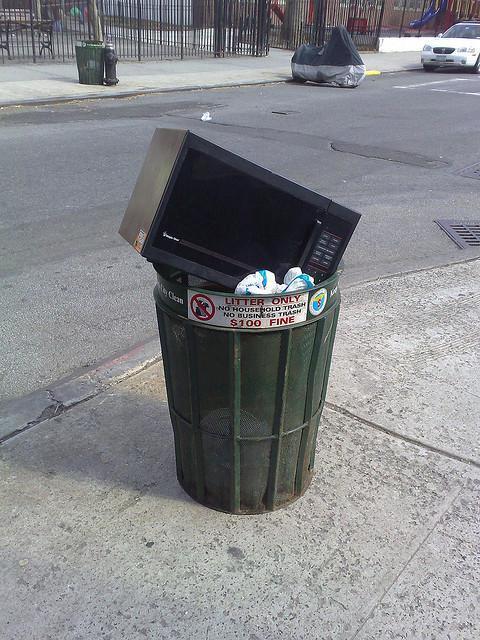How many suitcases are there?
Give a very brief answer. 0. 